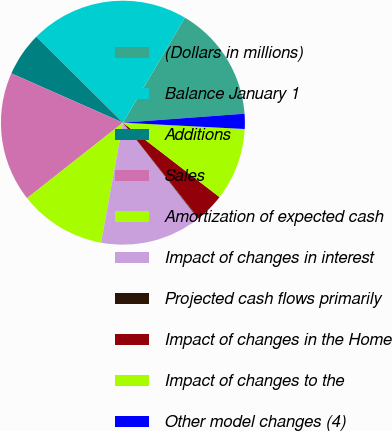<chart> <loc_0><loc_0><loc_500><loc_500><pie_chart><fcel>(Dollars in millions)<fcel>Balance January 1<fcel>Additions<fcel>Sales<fcel>Amortization of expected cash<fcel>Impact of changes in interest<fcel>Projected cash flows primarily<fcel>Impact of changes in the Home<fcel>Impact of changes to the<fcel>Other model changes (4)<nl><fcel>15.34%<fcel>21.05%<fcel>5.81%<fcel>17.24%<fcel>11.52%<fcel>13.43%<fcel>0.09%<fcel>3.9%<fcel>9.62%<fcel>2.0%<nl></chart> 